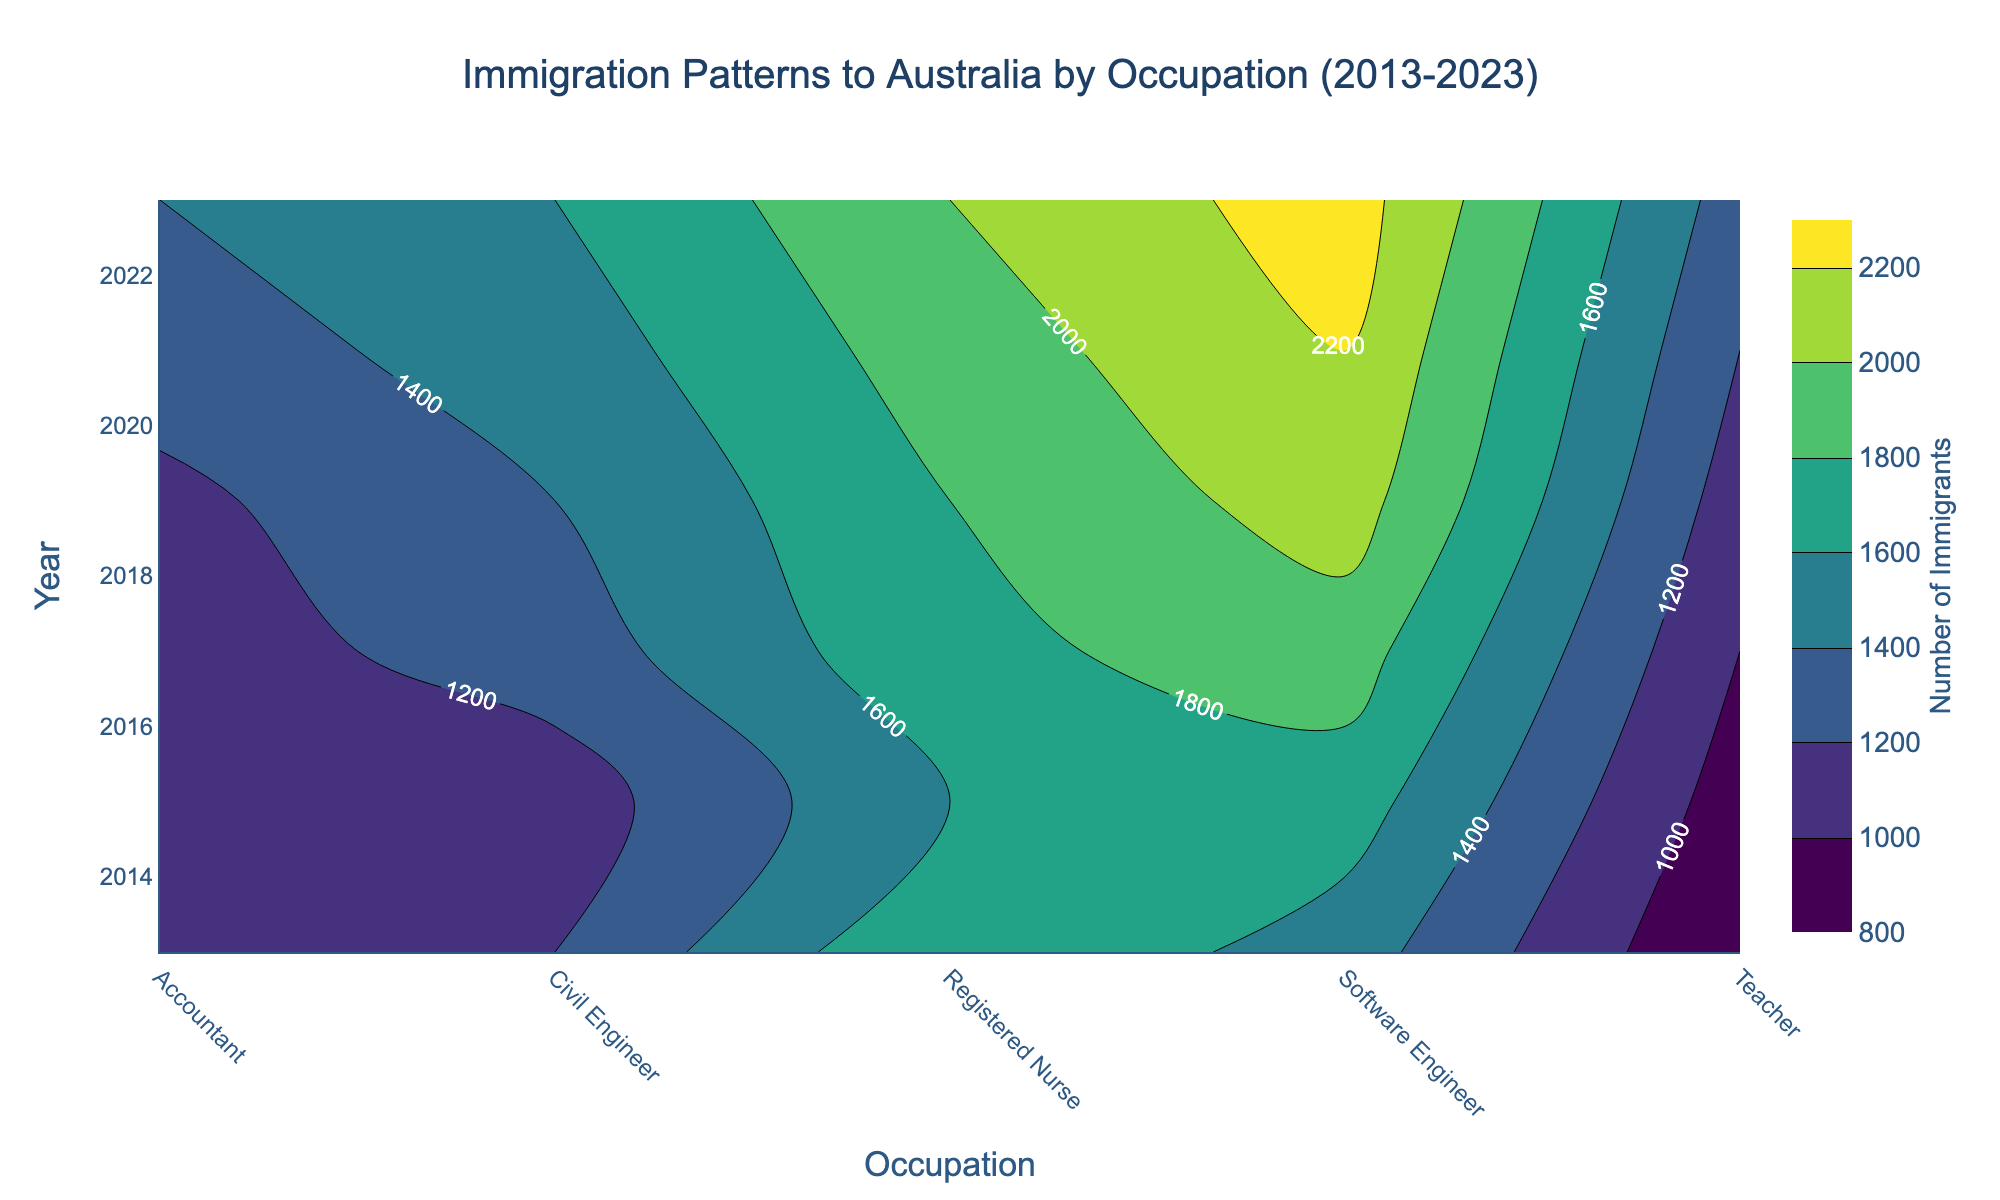What is the title of the plot? The title of the plot is found at the top of the figure and provides a summary of what the plot is about.
Answer: Immigration Patterns to Australia by Occupation (2013-2023) What does the color represent in the contour plot? The colors in the contour plot represent different levels or ranges of a variable, which can be identified by the color bar on the right side of the plot.
Answer: Number of Immigrants Between which years can you find the trend for the occupation 'Registered Nurse'? Look for the labels on the vertical axis that list the years from the bottom to the top, and find the range covered in the figure.
Answer: 2013-2023 Which occupation had the highest number of immigrants in the year 2023? Look at the labels along the bottom axis to find the column for the year 2023, then look at the contour labels for the highest value along that column.
Answer: Registered Nurse Which occupation saw the most significant increase in the number of immigrants from 2013 to 2023? Compare the contour lines and values across the years for each occupation to observe the changes and increases in scale or color intensity.
Answer: Software Engineer How did the number of immigrants for the 'Accountant' occupation change from 2013 to 2023? Follow the contour line for 'Accountant' from 2013 to 2023 and observe the changes in the labeled values.
Answer: It increased Which two years had the closest number of immigrants for the occupation 'Teacher'? Look at the contour lines for 'Teacher' across different years and find the two years with similar contour values or labels.
Answer: 2019 and 2021 What was the trend of immigrants for 'Civil Engineer' between 2017 and 2019? Look at the contour lines for 'Civil Engineer' over the specified years and analyze the trend in the numbers.
Answer: Increasing From the figure, which occupation has shown the least variation in the number of immigrants over the decade? Compare the contour lines for each occupation and identify the one with the most consistent or minimal changes.
Answer: Registered Nurse 